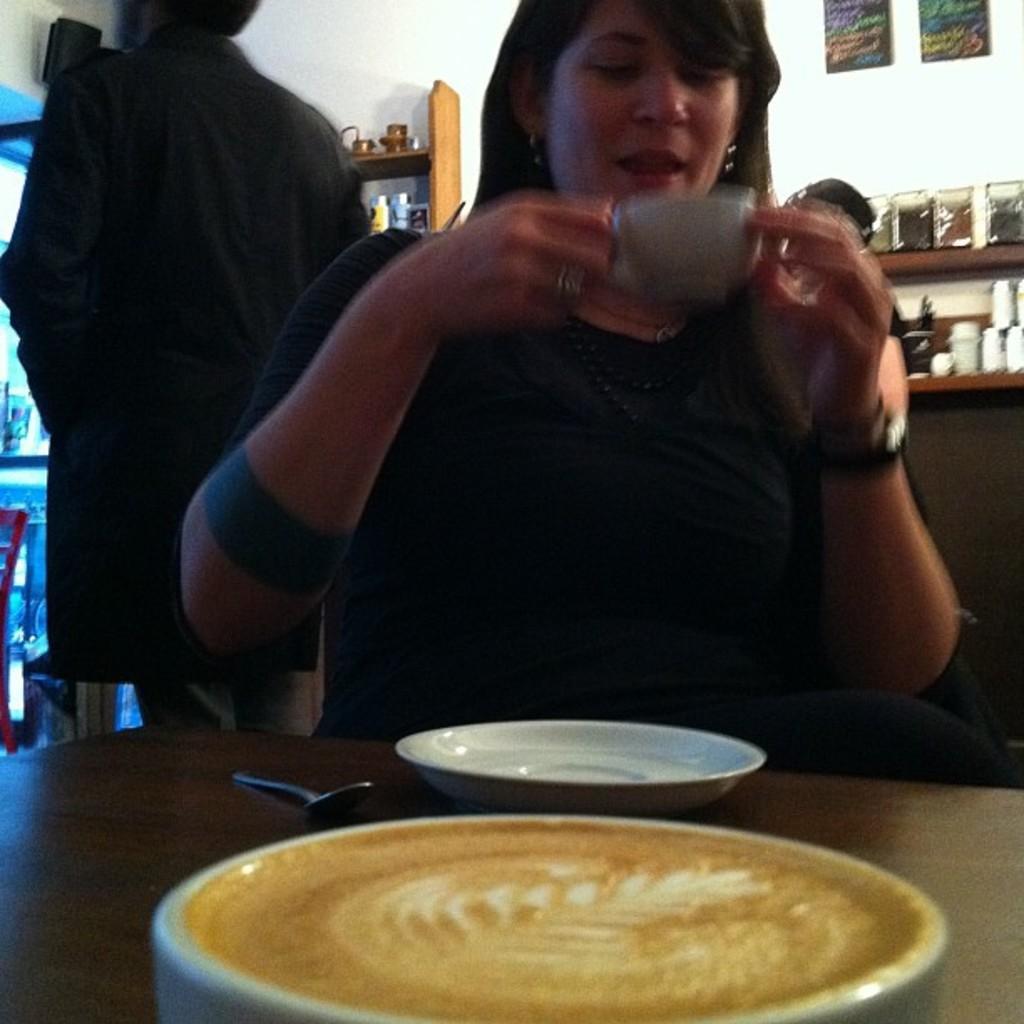Could you give a brief overview of what you see in this image? In this image I see a woman who is sitting and she is holding a cup and I see a table in front of her on which there is a plate, another cup and the spoon. In the background I see a person over here and I see few things on the racks and on the wall I see 2 papers. 